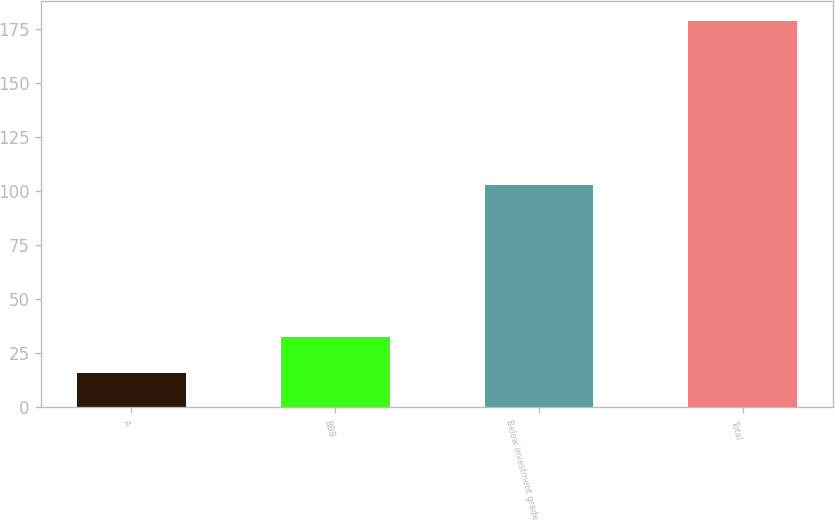<chart> <loc_0><loc_0><loc_500><loc_500><bar_chart><fcel>A<fcel>BBB<fcel>Below investment grade<fcel>Total<nl><fcel>16<fcel>32.3<fcel>103<fcel>179<nl></chart> 